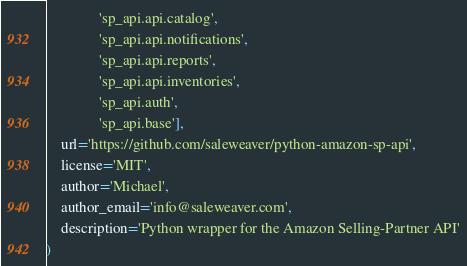<code> <loc_0><loc_0><loc_500><loc_500><_Python_>              'sp_api.api.catalog',
              'sp_api.api.notifications',
              'sp_api.api.reports',
              'sp_api.api.inventories',
              'sp_api.auth',
              'sp_api.base'],
    url='https://github.com/saleweaver/python-amazon-sp-api',
    license='MIT',
    author='Michael',
    author_email='info@saleweaver.com',
    description='Python wrapper for the Amazon Selling-Partner API'
)
</code> 